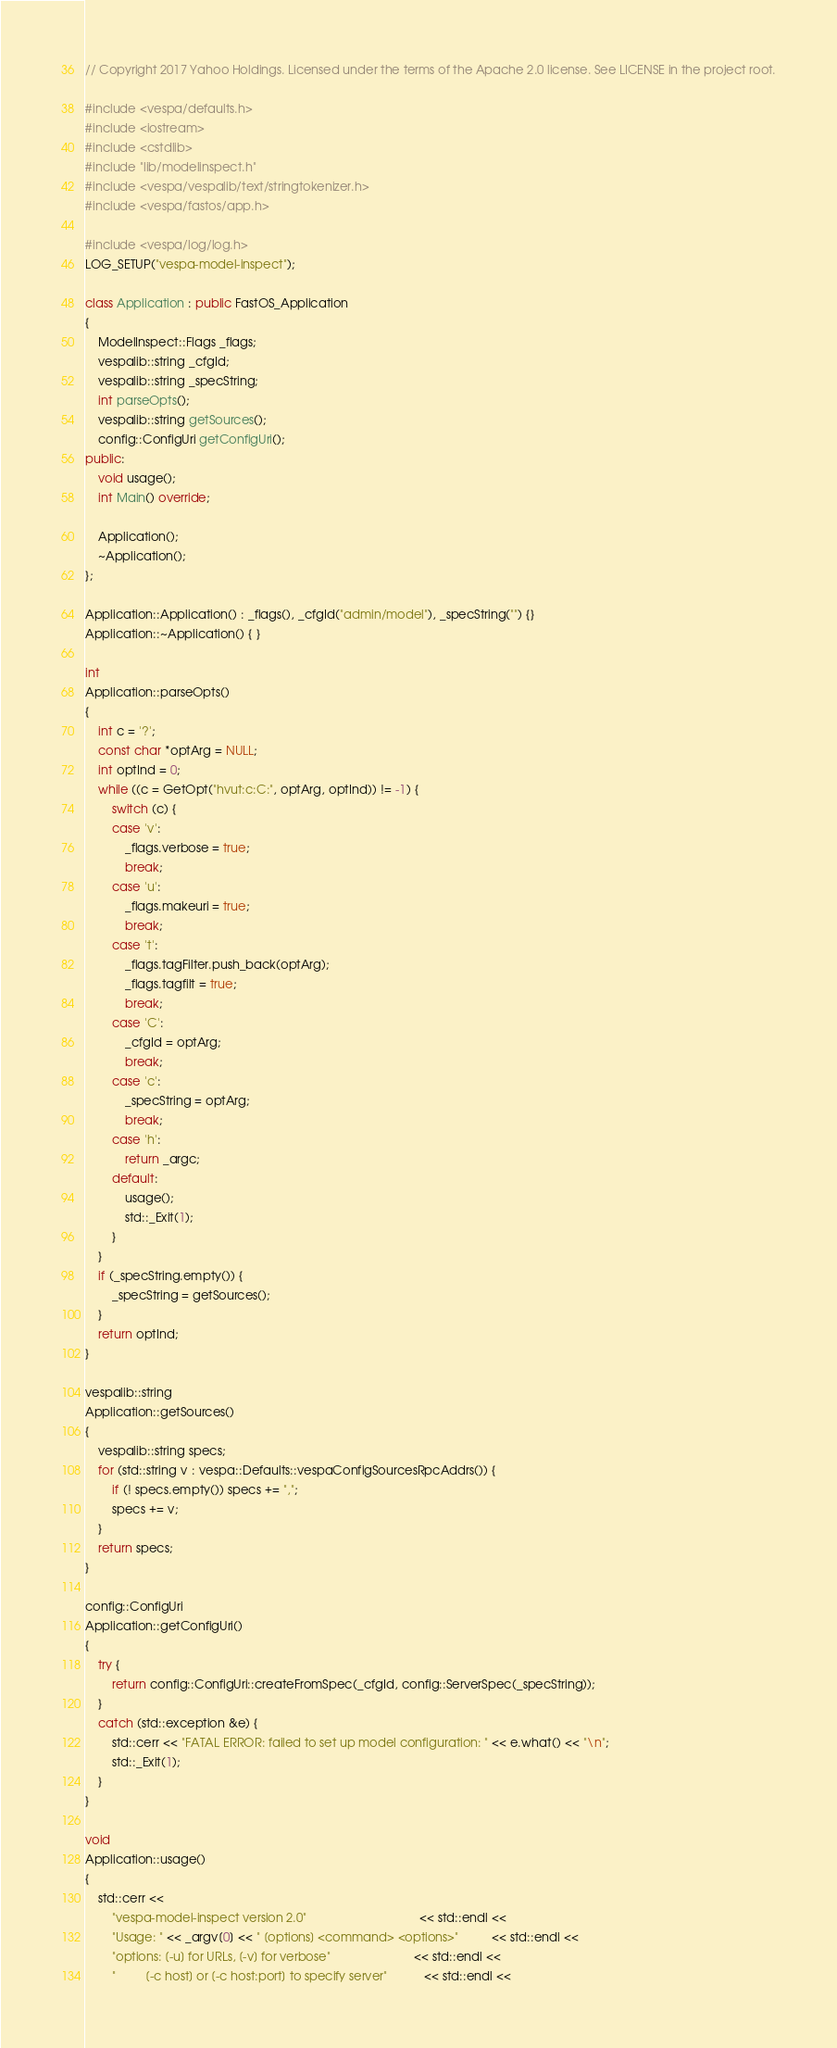<code> <loc_0><loc_0><loc_500><loc_500><_C++_>// Copyright 2017 Yahoo Holdings. Licensed under the terms of the Apache 2.0 license. See LICENSE in the project root.

#include <vespa/defaults.h>
#include <iostream>
#include <cstdlib>
#include "lib/modelinspect.h"
#include <vespa/vespalib/text/stringtokenizer.h>
#include <vespa/fastos/app.h>

#include <vespa/log/log.h>
LOG_SETUP("vespa-model-inspect");

class Application : public FastOS_Application
{
    ModelInspect::Flags _flags;
    vespalib::string _cfgId;
    vespalib::string _specString;
    int parseOpts();
    vespalib::string getSources();
    config::ConfigUri getConfigUri();
public:
    void usage();
    int Main() override;

    Application();
    ~Application();
};

Application::Application() : _flags(), _cfgId("admin/model"), _specString("") {}
Application::~Application() { }

int
Application::parseOpts()
{
    int c = '?';
    const char *optArg = NULL;
    int optInd = 0;
    while ((c = GetOpt("hvut:c:C:", optArg, optInd)) != -1) {
        switch (c) {
        case 'v':
            _flags.verbose = true;
            break;
        case 'u':
            _flags.makeuri = true;
            break;
        case 't':
            _flags.tagFilter.push_back(optArg);
            _flags.tagfilt = true;
            break;
        case 'C':
            _cfgId = optArg;
            break;
        case 'c':
            _specString = optArg;
            break;
        case 'h':
            return _argc;
        default:
            usage();
            std::_Exit(1);
        }
    }
    if (_specString.empty()) {
        _specString = getSources();
    }
    return optInd;
}

vespalib::string
Application::getSources()
{
    vespalib::string specs;
    for (std::string v : vespa::Defaults::vespaConfigSourcesRpcAddrs()) {
        if (! specs.empty()) specs += ",";
        specs += v;
    }
    return specs;
}

config::ConfigUri
Application::getConfigUri()
{
    try {
        return config::ConfigUri::createFromSpec(_cfgId, config::ServerSpec(_specString));
    }
    catch (std::exception &e) {
        std::cerr << "FATAL ERROR: failed to set up model configuration: " << e.what() << "\n";
        std::_Exit(1);
    }
}

void
Application::usage()
{
    std::cerr <<
        "vespa-model-inspect version 2.0"                                  << std::endl <<
        "Usage: " << _argv[0] << " [options] <command> <options>"          << std::endl <<
        "options: [-u] for URLs, [-v] for verbose"                         << std::endl <<
        "         [-c host] or [-c host:port] to specify server"           << std::endl <<</code> 